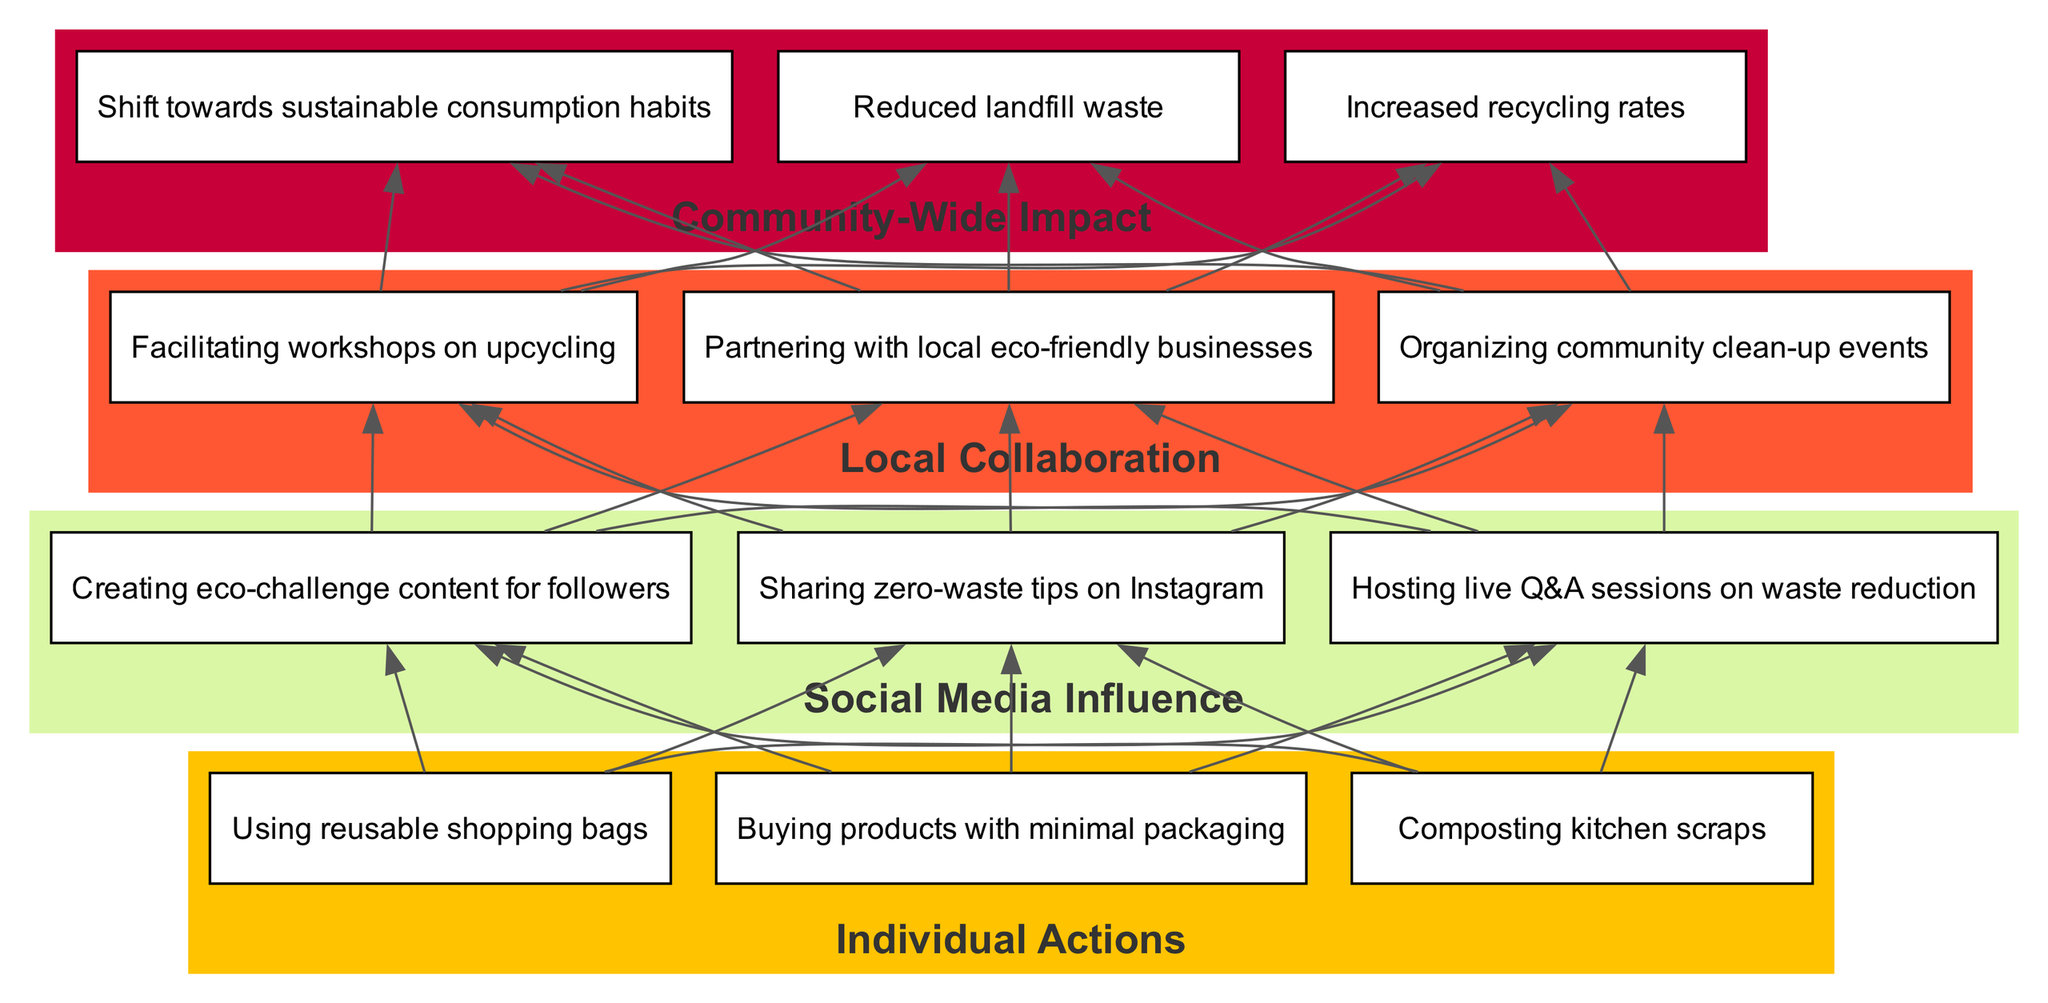What are three actions under Individual Actions? The diagram lists three actions categorized under Individual Actions: Composting kitchen scraps, Using reusable shopping bags, and Buying products with minimal packaging.
Answer: Composting kitchen scraps, Using reusable shopping bags, Buying products with minimal packaging How many elements are in the Social Media Influence category? The diagram shows that there are three elements listed under Social Media Influence: Sharing zero-waste tips on Instagram, Hosting live Q&A sessions on waste reduction, and Creating eco-challenge content for followers.
Answer: Three Which action directly leads to Local Collaboration? The diagram illustrates that actions under Social Media Influence provide the transition to Local Collaboration, particularly by achieving visibility and encouraging community engagement, although no specific action is indicated in the question.
Answer: Social Media Influence What is the primary impact of the community actions mapped out in the diagram? The diagram indicates the primary positive outcome of the community-wide efforts is the reduced landfill waste, which impacts environmental sustainability directly.
Answer: Reduced landfill waste How many edges connect Individual Actions to Social Media Influence? Each of the three nodes in the Individual Actions category is connected to each of the three nodes in the Social Media Influence category, resulting in a total of nine edges; each action influences multiple social media strategies.
Answer: Nine Which node in the Community-Wide Impact category suggests a change in behavior? The diagram indicates that the Shift towards sustainable consumption habits suggests a change in behavior among community members due to the previous actions taken at the individual and social media levels.
Answer: Shift towards sustainable consumption habits What color represents Local Collaboration in the diagram? The Local Collaboration category is represented by a distinct color code as defined in the diagram; it is colored with the second color from the scheme, which is a soft greenish shade.
Answer: Soft greenish shade Is there a direct line from Individual Actions to Community-Wide Impact? While there is no direct edge from the Individual Actions category to Community-Wide Impact in the diagram, the elements of each category are interconnected through Social Media Influence and Local Collaboration before reaching the community-wide outcomes.
Answer: No 